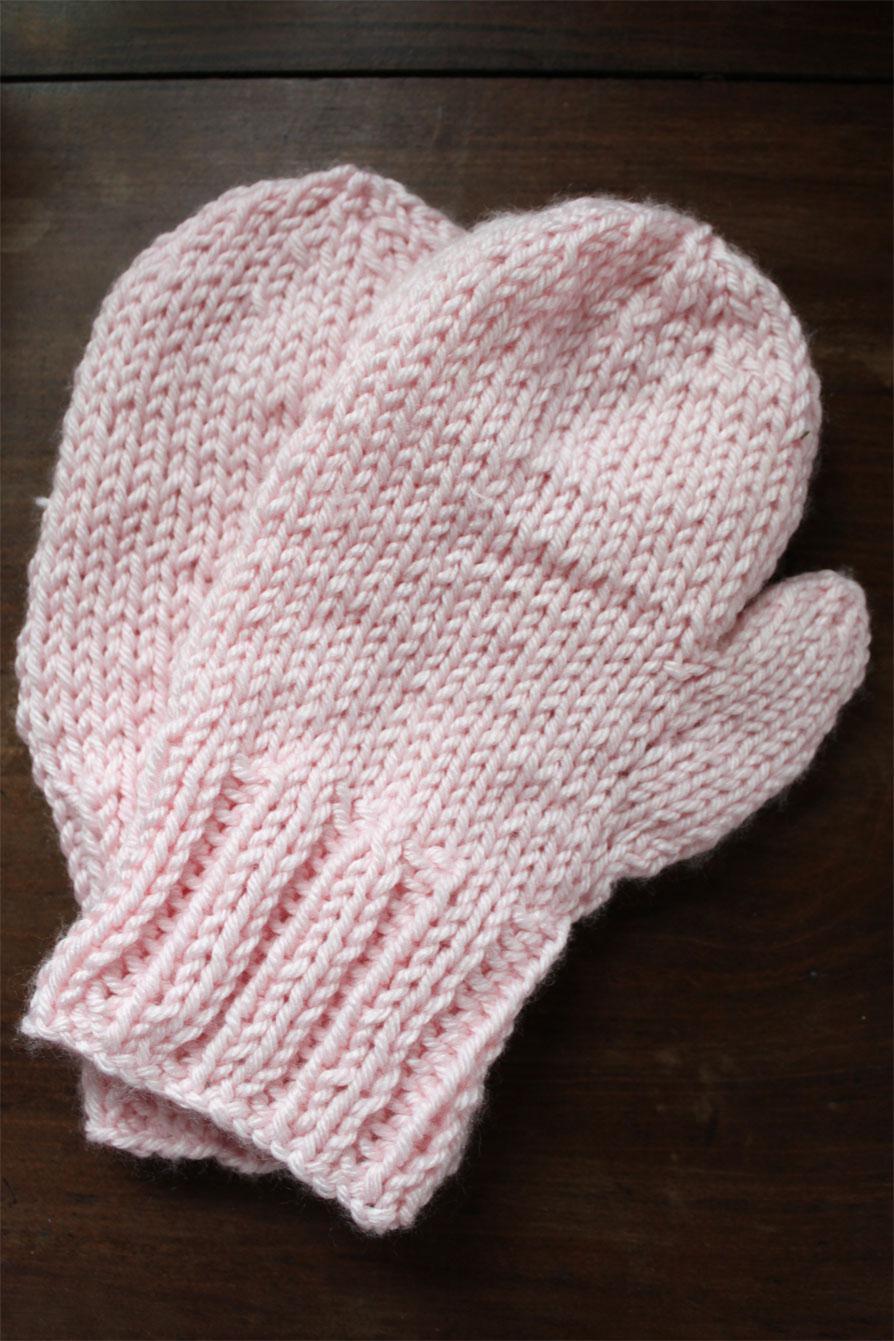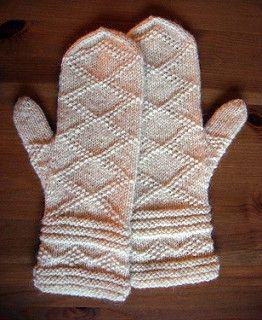The first image is the image on the left, the second image is the image on the right. Assess this claim about the two images: "The left and right image contains the same number of mittens.". Correct or not? Answer yes or no. Yes. 